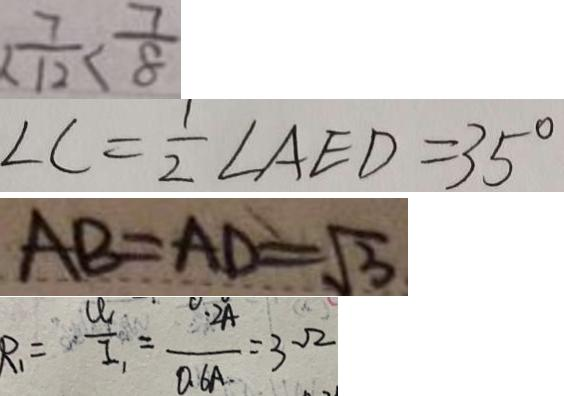<formula> <loc_0><loc_0><loc_500><loc_500>< \frac { 7 } { 1 2 } < \frac { 7 } { 8 } 
 \angle C = \frac { 1 } { 2 } \angle A E D = 3 5 ^ { \circ } 
 A B = A D = \sqrt { 3 } 
 R _ { 1 } = \frac { U _ { 1 } } { I _ { 1 } } = \frac { 0 . 2 A } { 0 . 6 A } = 3 \Omega</formula> 